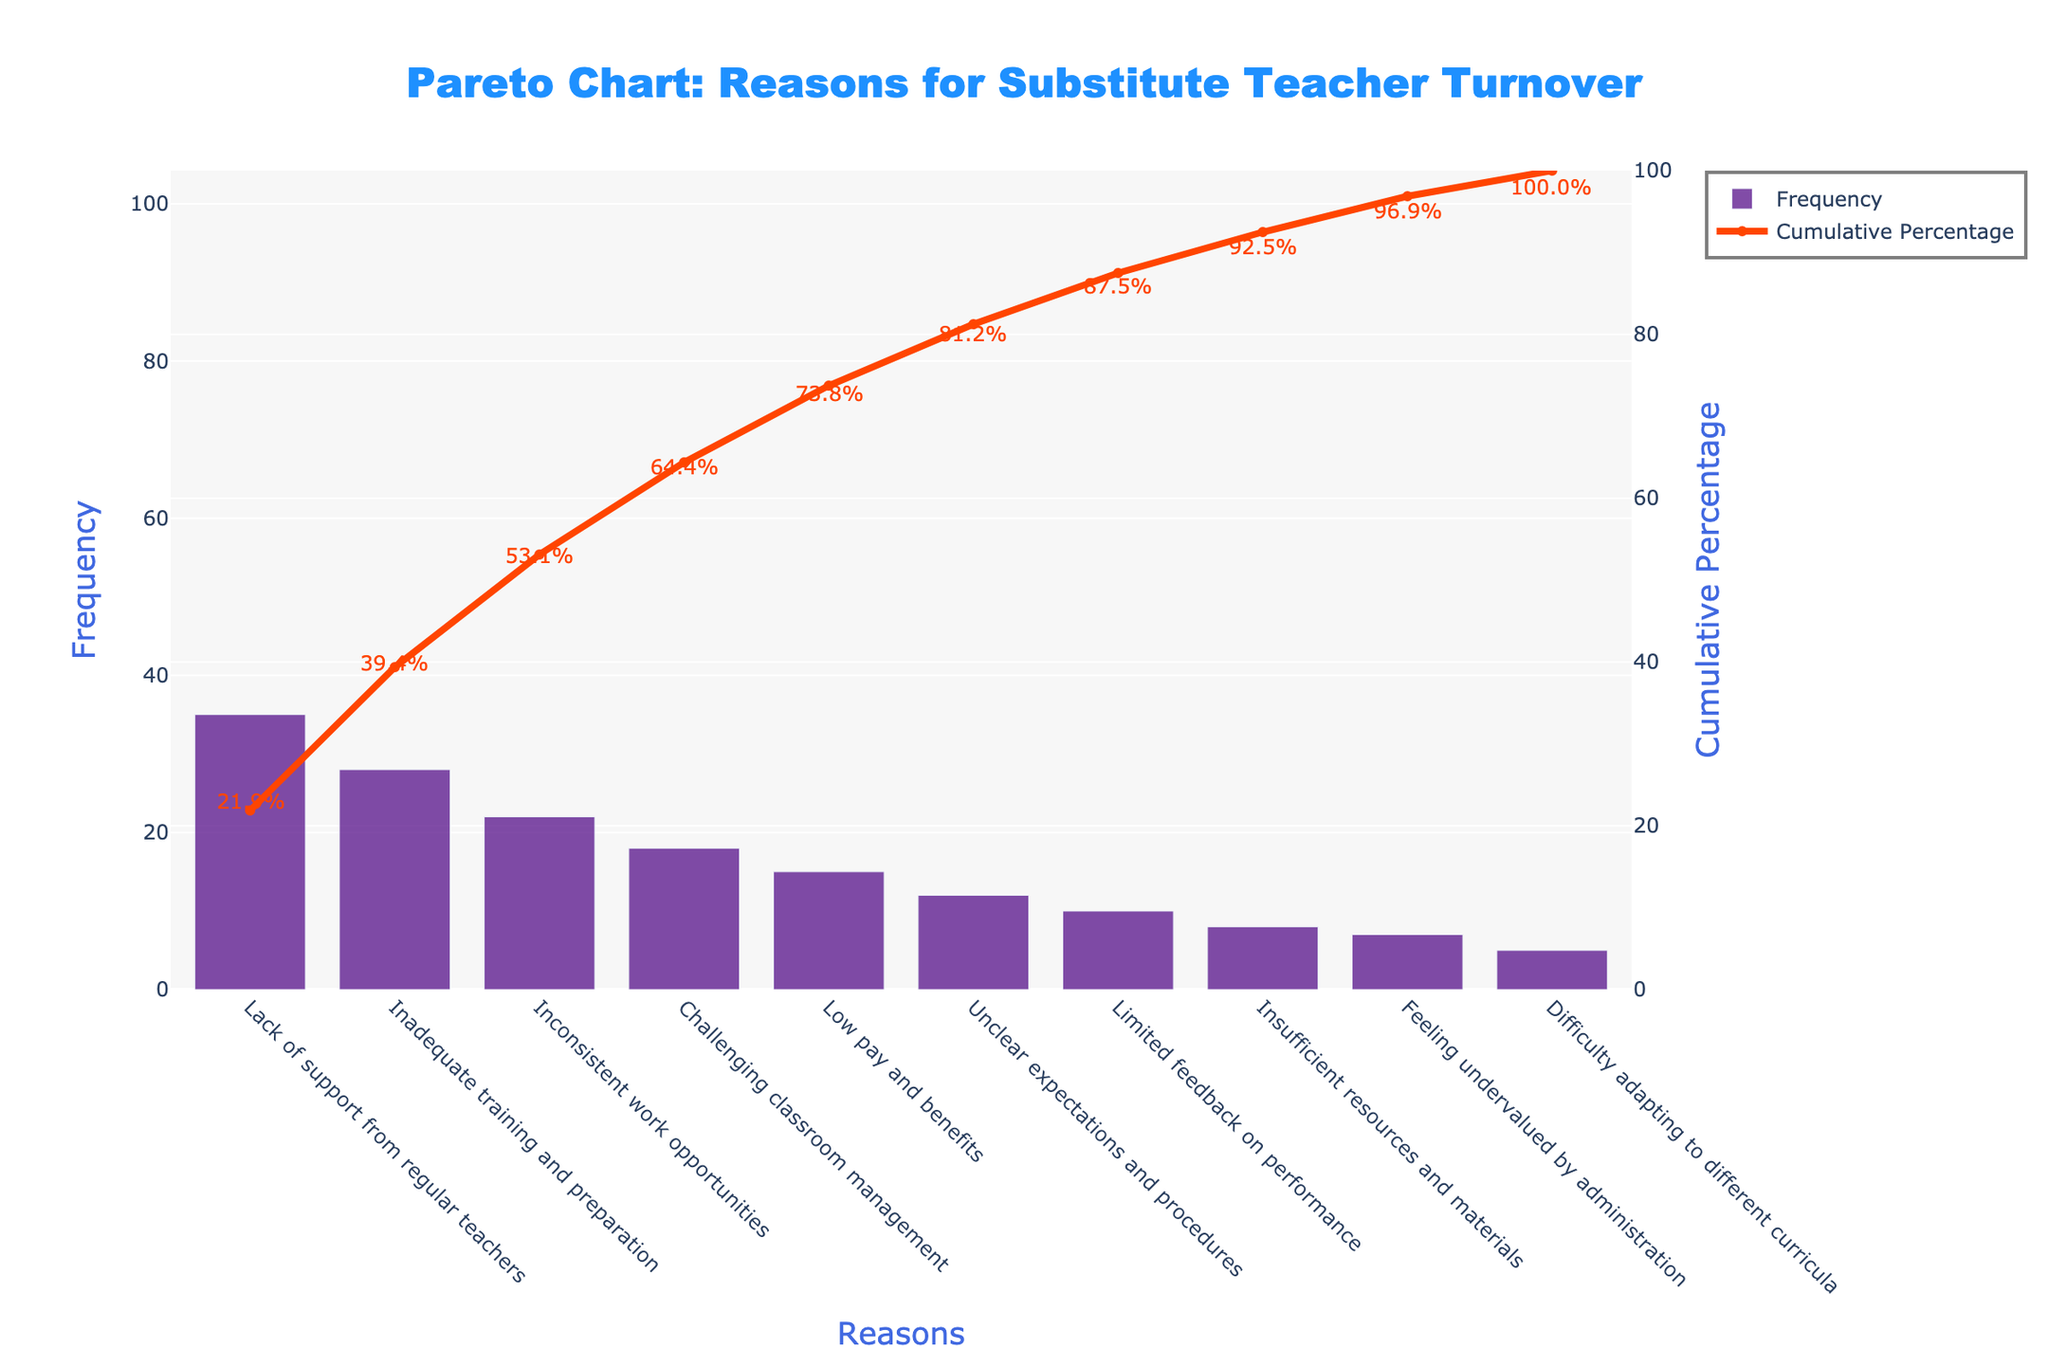what is the main reason for substitute teacher turnover presented in the chart? The highest bar represents the main reason for substitute teacher turnover. The bar labeled 'Lack of support from regular teachers' has the highest frequency.
Answer: Lack of support from regular teachers What is the cumulative percentage for the top two reasons combined? To get the cumulative percentage for the top two reasons, sum their frequencies and divide by the total frequency sum, then multiply by 100. The top two frequencies are 35 and 28, totaling 63. The total frequency sum is 160, and 63/160 * 100 ≈ 39.4%.
Answer: 39.4% Which reason has the lowest frequency, and what is its frequency? The shortest bar represents the reason with the lowest frequency. The bar labeled 'Difficulty adapting to different curricula' is the shortest, with a frequency of 5.
Answer: Difficulty adapting to different curricula, 5 How does the frequency of 'Inconsistent work opportunities' compare to 'Low pay and benefits'? Check the heights of the bars labeled 'Inconsistent work opportunities' and 'Low pay and benefits.' The bar for 'Inconsistent work opportunities' is taller, indicating a higher frequency.
Answer: Inconsistent work opportunities is higher What is the cumulative percentage after the fifth reason? To find the cumulative percentage after the fifth reason, sum up the frequencies of the top five reasons and divide by the total frequency sum, then multiply by 100. The top five frequencies are 35, 28, 22, 18, and 15, totaling 118. The total frequency sum is 160, and 118/160 * 100 = 73.75%.
Answer: 73.75% Identify two reasons whose combined frequency is equal to the frequency of 'Lack of support from regular teachers'. Add frequencies to find combinations that match the highest frequency (35). The frequencies of 'Unclear expectations and procedures' (12) and 'Limited feedback on performance' (10) combined with 'Difficulty adapting to different curricula' (5) equal 35 (12+10+5=27). Adjust other pairings. 'Inadequate training and preparation' (28) and 'Feeling undervalued by administration' (7) equal 35 (28+7=35).
Answer: Inadequate training and preparation, Feeling undervalued by administration 